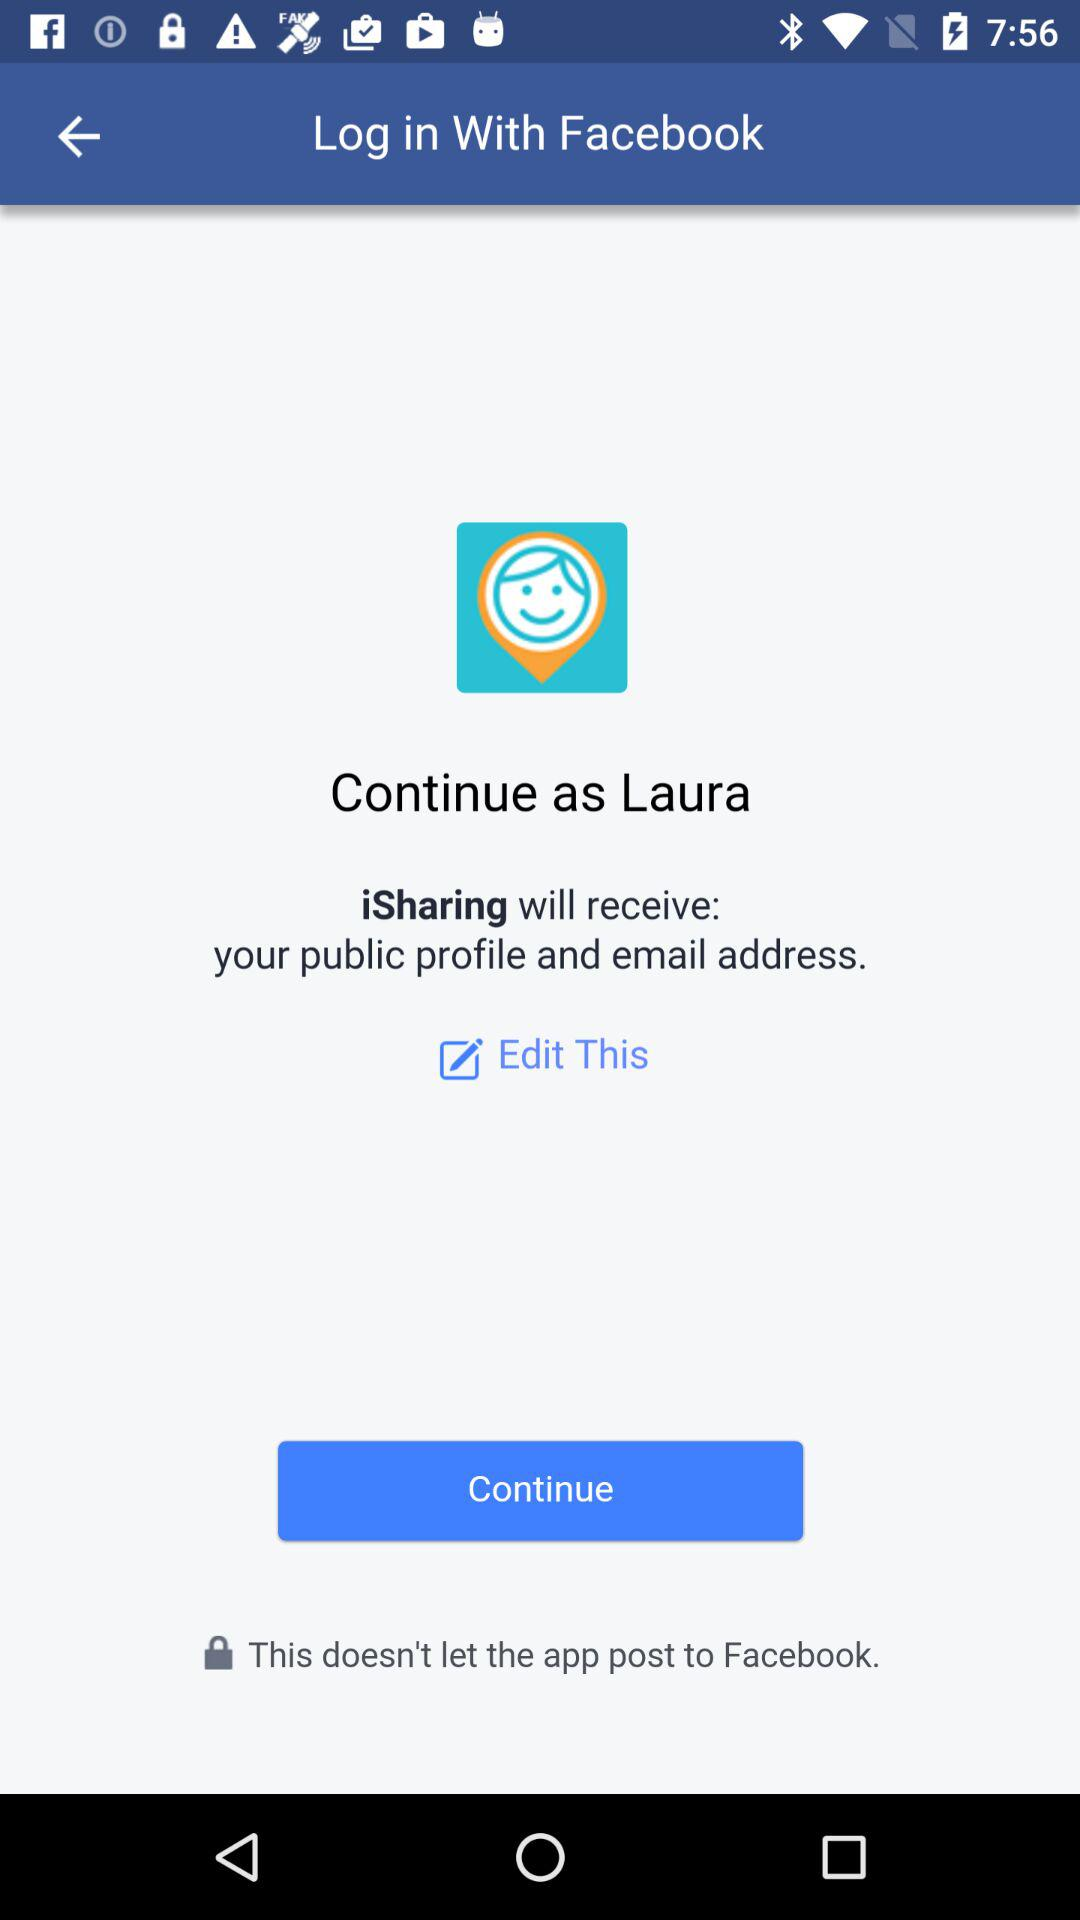What application is asking for permission? The application asking for permission is "iSharing". 